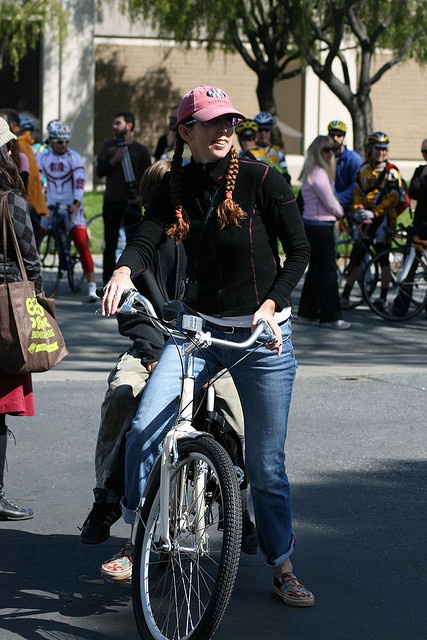Describe the objects in this image and their specific colors. I can see people in darkgray, black, navy, lightgray, and gray tones, bicycle in darkgray, black, gray, and white tones, people in darkgray, black, gray, and lightgray tones, people in darkgray, black, gray, and maroon tones, and people in darkgray, black, gray, and lavender tones in this image. 